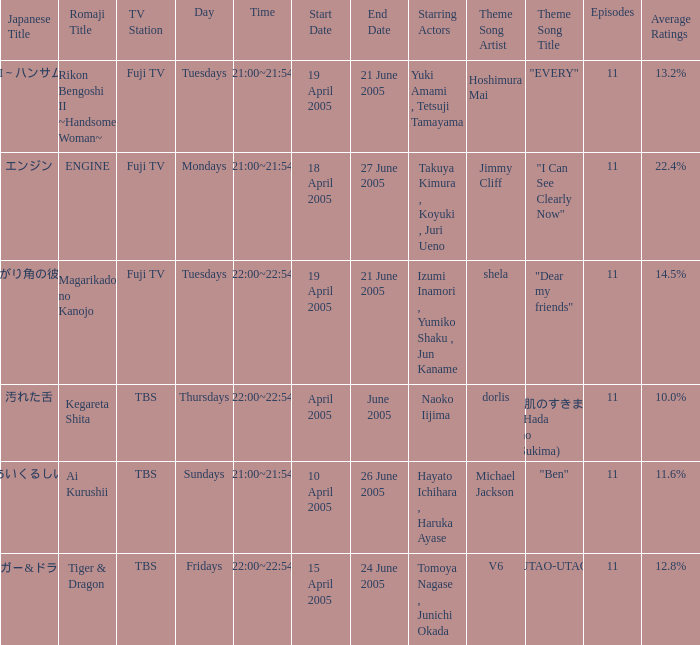What is the Japanese title with an average rating of 11.6%? あいくるしい. 